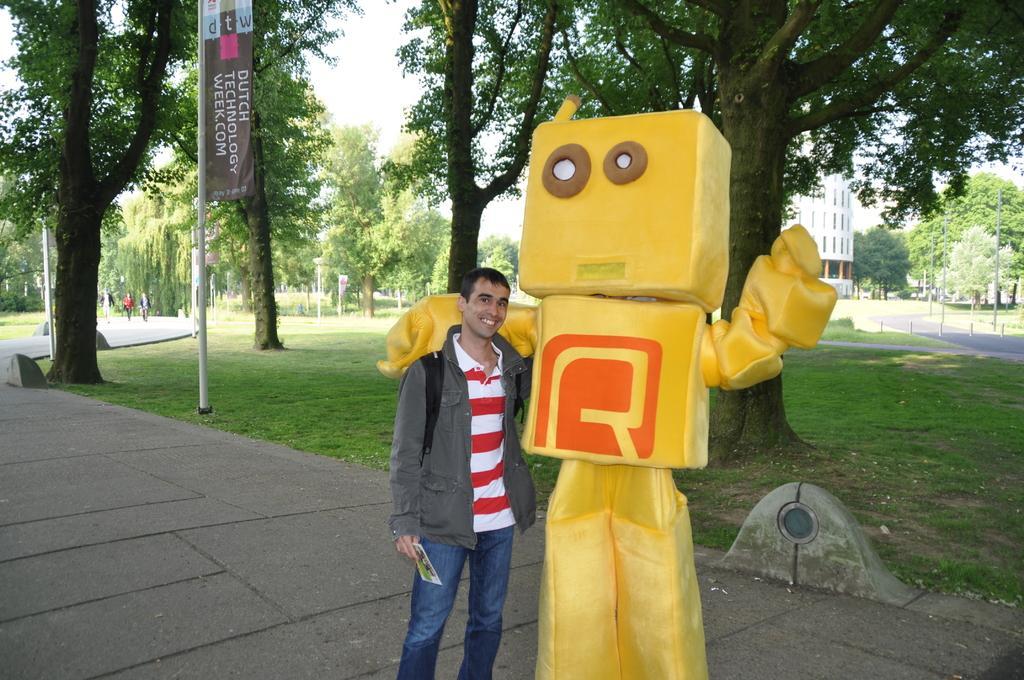Could you give a brief overview of what you see in this image? In this image I can see a person wearing red and white t shirt, jacket and jeans is standing and another person wearing yellow and orange colored costume is standing beside him. In the background I can see the ground, some grass, a pole, few trees, a building, few persons on the road and the sky. 